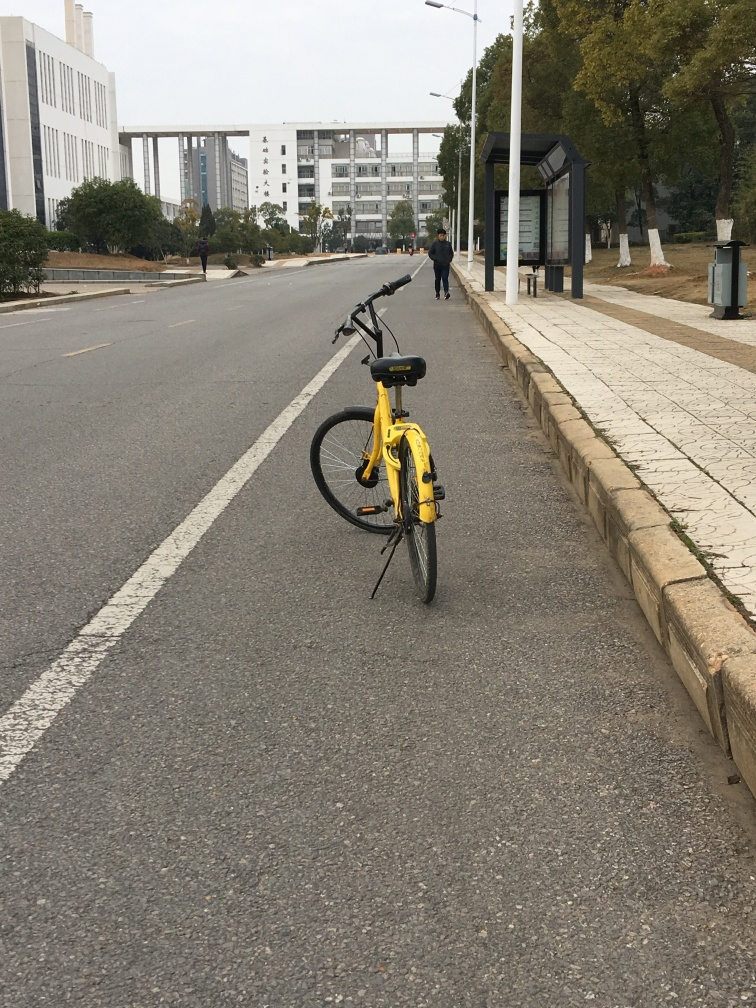Describe the overall atmosphere of the area in the photograph. The area seems to have a serene atmosphere, imparted by the calm, quiet street that is not crowded with traffic. The overcast weather contributes to a subdued tone, and the presence of open spaces and greenery alongside the roads lends a sense of openness and tranquility. 